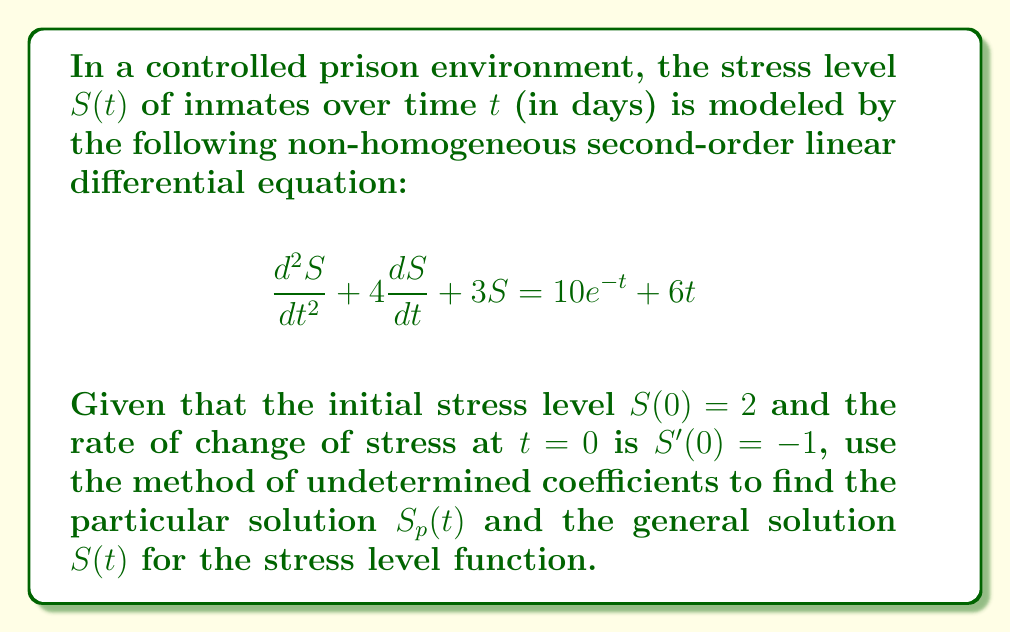Help me with this question. Let's solve this step-by-step using the method of undetermined coefficients:

1) The complementary solution $S_c(t)$ is found by solving the homogeneous equation:
   $$\frac{d^2S}{dt^2} + 4\frac{dS}{dt} + 3S = 0$$
   The characteristic equation is $r^2 + 4r + 3 = 0$
   Solving this, we get $r = -1$ or $r = -3$
   So, $S_c(t) = c_1e^{-t} + c_2e^{-3t}$

2) For the particular solution $S_p(t)$, we need to consider both $10e^{-t}$ and $6t$:
   For $10e^{-t}$, we use $Ae^{-t}$
   For $6t$, we use $Bt + C$

   So, $S_p(t) = Ae^{-t} + Bt + C$

3) Substitute this into the original equation:
   $$(A)e^{-t} + B + (-A)e^{-t} + 4(-A)e^{-t} + 4B + 3(Ae^{-t} + Bt + C) = 10e^{-t} + 6t$$

4) Equating coefficients:
   $e^{-t}$: $-2A = 10$, so $A = -5$
   $t$: $3B = 6$, so $B = 2$
   constant: $4B + 3C = 0$, so $C = -\frac{8}{3}$

5) Therefore, $S_p(t) = -5e^{-t} + 2t - \frac{8}{3}$

6) The general solution is $S(t) = S_c(t) + S_p(t)$:
   $$S(t) = c_1e^{-t} + c_2e^{-3t} - 5e^{-t} + 2t - \frac{8}{3}$$

7) Using the initial conditions:
   $S(0) = 2$: $c_1 + c_2 - 5 - \frac{8}{3} = 2$
   $S'(0) = -1$: $-c_1 - 3c_2 + 5 + 2 = -1$

8) Solving these equations:
   $c_1 = \frac{37}{3}$, $c_2 = -\frac{4}{3}$

9) The final solution is:
   $$S(t) = \frac{37}{3}e^{-t} - \frac{4}{3}e^{-3t} - 5e^{-t} + 2t - \frac{8}{3}$$
Answer: $S(t) = \frac{37}{3}e^{-t} - \frac{4}{3}e^{-3t} - 5e^{-t} + 2t - \frac{8}{3}$ 